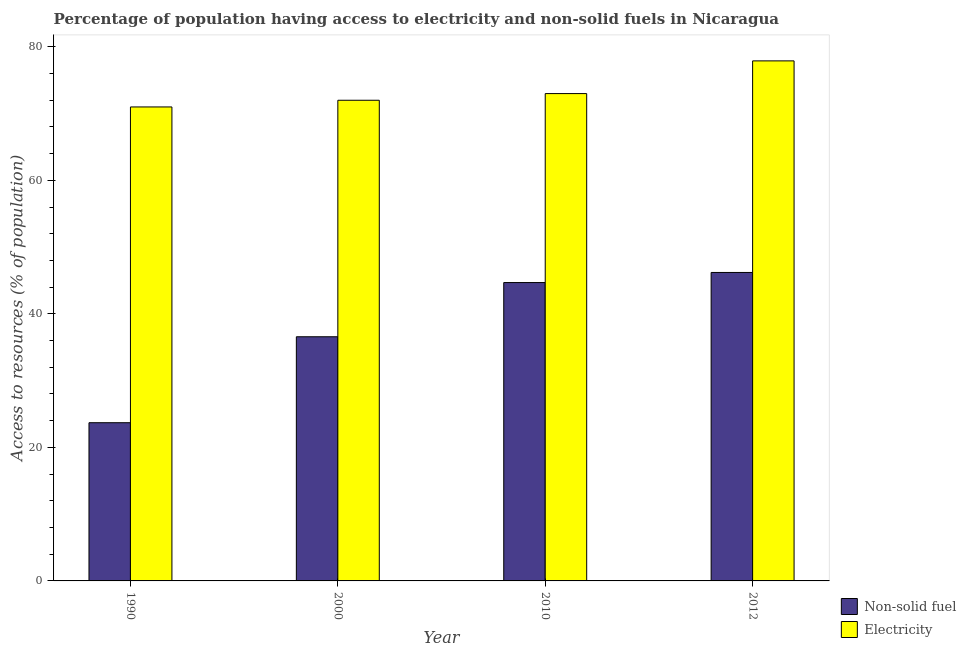How many different coloured bars are there?
Keep it short and to the point. 2. How many groups of bars are there?
Offer a terse response. 4. Are the number of bars on each tick of the X-axis equal?
Keep it short and to the point. Yes. What is the percentage of population having access to non-solid fuel in 2012?
Your answer should be very brief. 46.21. Across all years, what is the maximum percentage of population having access to electricity?
Offer a very short reply. 77.9. Across all years, what is the minimum percentage of population having access to non-solid fuel?
Provide a succinct answer. 23.7. In which year was the percentage of population having access to non-solid fuel maximum?
Offer a terse response. 2012. In which year was the percentage of population having access to non-solid fuel minimum?
Your answer should be compact. 1990. What is the total percentage of population having access to non-solid fuel in the graph?
Offer a very short reply. 151.17. What is the difference between the percentage of population having access to electricity in 1990 and that in 2000?
Your answer should be compact. -1. What is the difference between the percentage of population having access to non-solid fuel in 2012 and the percentage of population having access to electricity in 2010?
Offer a terse response. 1.51. What is the average percentage of population having access to non-solid fuel per year?
Keep it short and to the point. 37.79. In the year 1990, what is the difference between the percentage of population having access to electricity and percentage of population having access to non-solid fuel?
Your answer should be very brief. 0. What is the ratio of the percentage of population having access to non-solid fuel in 2000 to that in 2012?
Give a very brief answer. 0.79. Is the percentage of population having access to electricity in 2000 less than that in 2012?
Offer a terse response. Yes. What is the difference between the highest and the second highest percentage of population having access to non-solid fuel?
Your response must be concise. 1.51. What is the difference between the highest and the lowest percentage of population having access to non-solid fuel?
Your response must be concise. 22.51. What does the 2nd bar from the left in 2010 represents?
Your response must be concise. Electricity. What does the 2nd bar from the right in 2012 represents?
Give a very brief answer. Non-solid fuel. How many bars are there?
Provide a short and direct response. 8. How many years are there in the graph?
Ensure brevity in your answer.  4. Are the values on the major ticks of Y-axis written in scientific E-notation?
Offer a terse response. No. Does the graph contain grids?
Give a very brief answer. No. Where does the legend appear in the graph?
Keep it short and to the point. Bottom right. How are the legend labels stacked?
Give a very brief answer. Vertical. What is the title of the graph?
Your answer should be compact. Percentage of population having access to electricity and non-solid fuels in Nicaragua. What is the label or title of the Y-axis?
Your response must be concise. Access to resources (% of population). What is the Access to resources (% of population) in Non-solid fuel in 1990?
Your response must be concise. 23.7. What is the Access to resources (% of population) in Electricity in 1990?
Your answer should be very brief. 71. What is the Access to resources (% of population) of Non-solid fuel in 2000?
Your response must be concise. 36.57. What is the Access to resources (% of population) in Electricity in 2000?
Offer a terse response. 72. What is the Access to resources (% of population) of Non-solid fuel in 2010?
Offer a very short reply. 44.69. What is the Access to resources (% of population) in Non-solid fuel in 2012?
Your response must be concise. 46.21. What is the Access to resources (% of population) of Electricity in 2012?
Make the answer very short. 77.9. Across all years, what is the maximum Access to resources (% of population) in Non-solid fuel?
Your answer should be compact. 46.21. Across all years, what is the maximum Access to resources (% of population) of Electricity?
Give a very brief answer. 77.9. Across all years, what is the minimum Access to resources (% of population) of Non-solid fuel?
Your answer should be very brief. 23.7. What is the total Access to resources (% of population) of Non-solid fuel in the graph?
Your response must be concise. 151.17. What is the total Access to resources (% of population) in Electricity in the graph?
Your answer should be very brief. 293.9. What is the difference between the Access to resources (% of population) in Non-solid fuel in 1990 and that in 2000?
Offer a very short reply. -12.88. What is the difference between the Access to resources (% of population) of Non-solid fuel in 1990 and that in 2010?
Give a very brief answer. -21. What is the difference between the Access to resources (% of population) in Non-solid fuel in 1990 and that in 2012?
Your response must be concise. -22.51. What is the difference between the Access to resources (% of population) in Non-solid fuel in 2000 and that in 2010?
Your answer should be compact. -8.12. What is the difference between the Access to resources (% of population) of Non-solid fuel in 2000 and that in 2012?
Keep it short and to the point. -9.63. What is the difference between the Access to resources (% of population) of Electricity in 2000 and that in 2012?
Offer a very short reply. -5.9. What is the difference between the Access to resources (% of population) in Non-solid fuel in 2010 and that in 2012?
Ensure brevity in your answer.  -1.51. What is the difference between the Access to resources (% of population) of Non-solid fuel in 1990 and the Access to resources (% of population) of Electricity in 2000?
Provide a succinct answer. -48.3. What is the difference between the Access to resources (% of population) in Non-solid fuel in 1990 and the Access to resources (% of population) in Electricity in 2010?
Make the answer very short. -49.3. What is the difference between the Access to resources (% of population) of Non-solid fuel in 1990 and the Access to resources (% of population) of Electricity in 2012?
Your response must be concise. -54.2. What is the difference between the Access to resources (% of population) in Non-solid fuel in 2000 and the Access to resources (% of population) in Electricity in 2010?
Your answer should be very brief. -36.43. What is the difference between the Access to resources (% of population) of Non-solid fuel in 2000 and the Access to resources (% of population) of Electricity in 2012?
Your answer should be compact. -41.33. What is the difference between the Access to resources (% of population) of Non-solid fuel in 2010 and the Access to resources (% of population) of Electricity in 2012?
Your answer should be compact. -33.21. What is the average Access to resources (% of population) in Non-solid fuel per year?
Your answer should be compact. 37.79. What is the average Access to resources (% of population) in Electricity per year?
Your response must be concise. 73.47. In the year 1990, what is the difference between the Access to resources (% of population) of Non-solid fuel and Access to resources (% of population) of Electricity?
Offer a terse response. -47.3. In the year 2000, what is the difference between the Access to resources (% of population) in Non-solid fuel and Access to resources (% of population) in Electricity?
Offer a terse response. -35.43. In the year 2010, what is the difference between the Access to resources (% of population) of Non-solid fuel and Access to resources (% of population) of Electricity?
Ensure brevity in your answer.  -28.31. In the year 2012, what is the difference between the Access to resources (% of population) in Non-solid fuel and Access to resources (% of population) in Electricity?
Your answer should be very brief. -31.69. What is the ratio of the Access to resources (% of population) of Non-solid fuel in 1990 to that in 2000?
Make the answer very short. 0.65. What is the ratio of the Access to resources (% of population) of Electricity in 1990 to that in 2000?
Offer a very short reply. 0.99. What is the ratio of the Access to resources (% of population) of Non-solid fuel in 1990 to that in 2010?
Give a very brief answer. 0.53. What is the ratio of the Access to resources (% of population) of Electricity in 1990 to that in 2010?
Provide a short and direct response. 0.97. What is the ratio of the Access to resources (% of population) in Non-solid fuel in 1990 to that in 2012?
Keep it short and to the point. 0.51. What is the ratio of the Access to resources (% of population) in Electricity in 1990 to that in 2012?
Offer a terse response. 0.91. What is the ratio of the Access to resources (% of population) in Non-solid fuel in 2000 to that in 2010?
Keep it short and to the point. 0.82. What is the ratio of the Access to resources (% of population) of Electricity in 2000 to that in 2010?
Your answer should be compact. 0.99. What is the ratio of the Access to resources (% of population) in Non-solid fuel in 2000 to that in 2012?
Keep it short and to the point. 0.79. What is the ratio of the Access to resources (% of population) in Electricity in 2000 to that in 2012?
Offer a terse response. 0.92. What is the ratio of the Access to resources (% of population) of Non-solid fuel in 2010 to that in 2012?
Provide a short and direct response. 0.97. What is the ratio of the Access to resources (% of population) in Electricity in 2010 to that in 2012?
Provide a succinct answer. 0.94. What is the difference between the highest and the second highest Access to resources (% of population) of Non-solid fuel?
Ensure brevity in your answer.  1.51. What is the difference between the highest and the second highest Access to resources (% of population) in Electricity?
Make the answer very short. 4.9. What is the difference between the highest and the lowest Access to resources (% of population) in Non-solid fuel?
Offer a terse response. 22.51. What is the difference between the highest and the lowest Access to resources (% of population) in Electricity?
Offer a terse response. 6.9. 